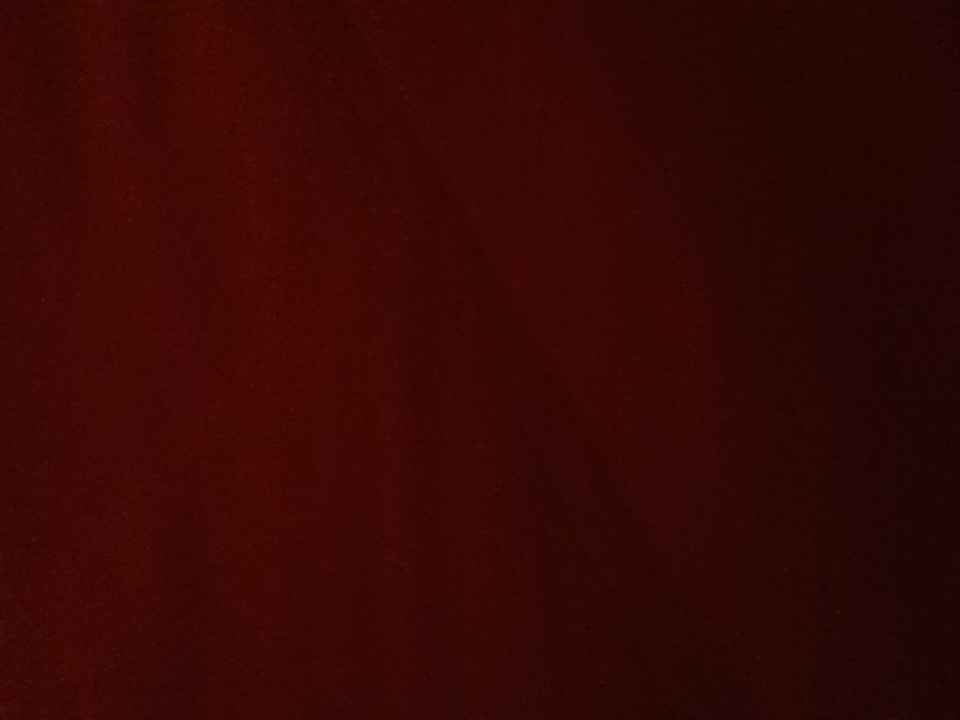What might this color mean in different cultures? In different cultures, the color red can have a variety of meanings. In many Western cultures, red is often associated with love, passion, and excitement. In Chinese culture, red is a symbol of good luck, happiness, and prosperity, often used in celebrations and festivals. In some African cultures, red can signify mourning and death. Context and specific shades may alter these associations, but red generally holds strong symbolic and emotional significance globally. Can you tell me a story involving this color? Once upon a time, in a kingdom renowned for its lush landscapes, there was an enchanted forest known for its rare natural phenomena. At the heart of this forest stood the ancient Tree of Echo, whose leaves turned a deep, mesmerizing red each autumn. Local legend had it that the tree's color was imbued with the essence of the forest's magic, reflecting the passion and strength of the kingdom's people. Every year, when the leaves transformed, villagers from far and wide would gather for a festival of unity and gratitude, celebrating their heritage and the enduring spirit of their community. 